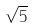Convert formula to latex. <formula><loc_0><loc_0><loc_500><loc_500>\sqrt { 5 }</formula> 